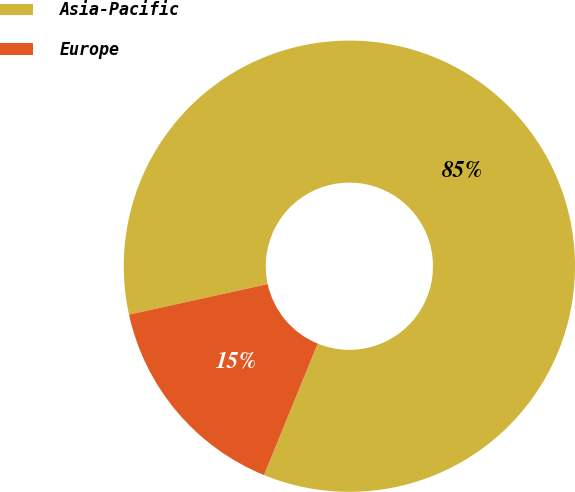Convert chart. <chart><loc_0><loc_0><loc_500><loc_500><pie_chart><fcel>Asia-Pacific<fcel>Europe<nl><fcel>84.62%<fcel>15.38%<nl></chart> 